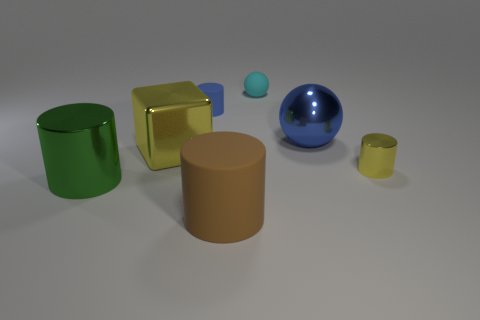Add 3 brown metallic things. How many objects exist? 10 Subtract all cubes. How many objects are left? 6 Subtract all red shiny balls. Subtract all big brown objects. How many objects are left? 6 Add 1 metal cylinders. How many metal cylinders are left? 3 Add 3 small rubber cylinders. How many small rubber cylinders exist? 4 Subtract 1 yellow cylinders. How many objects are left? 6 